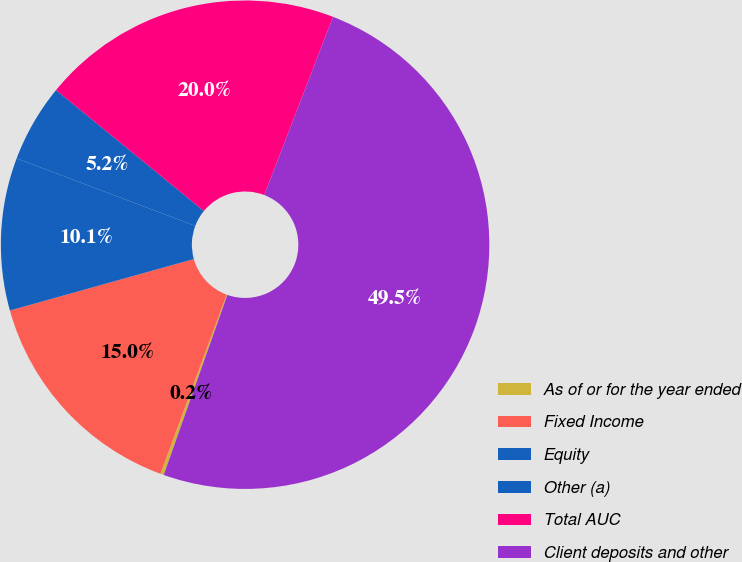Convert chart to OTSL. <chart><loc_0><loc_0><loc_500><loc_500><pie_chart><fcel>As of or for the year ended<fcel>Fixed Income<fcel>Equity<fcel>Other (a)<fcel>Total AUC<fcel>Client deposits and other<nl><fcel>0.23%<fcel>15.02%<fcel>10.09%<fcel>5.16%<fcel>19.95%<fcel>49.54%<nl></chart> 